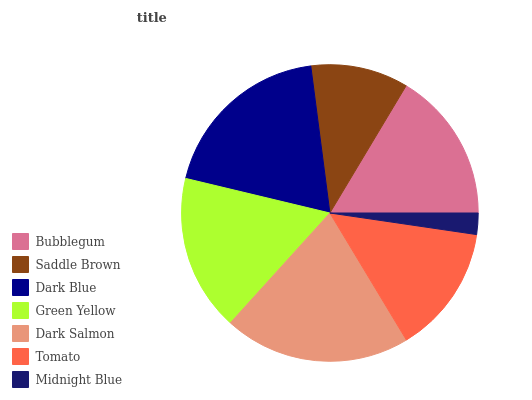Is Midnight Blue the minimum?
Answer yes or no. Yes. Is Dark Salmon the maximum?
Answer yes or no. Yes. Is Saddle Brown the minimum?
Answer yes or no. No. Is Saddle Brown the maximum?
Answer yes or no. No. Is Bubblegum greater than Saddle Brown?
Answer yes or no. Yes. Is Saddle Brown less than Bubblegum?
Answer yes or no. Yes. Is Saddle Brown greater than Bubblegum?
Answer yes or no. No. Is Bubblegum less than Saddle Brown?
Answer yes or no. No. Is Bubblegum the high median?
Answer yes or no. Yes. Is Bubblegum the low median?
Answer yes or no. Yes. Is Midnight Blue the high median?
Answer yes or no. No. Is Dark Salmon the low median?
Answer yes or no. No. 